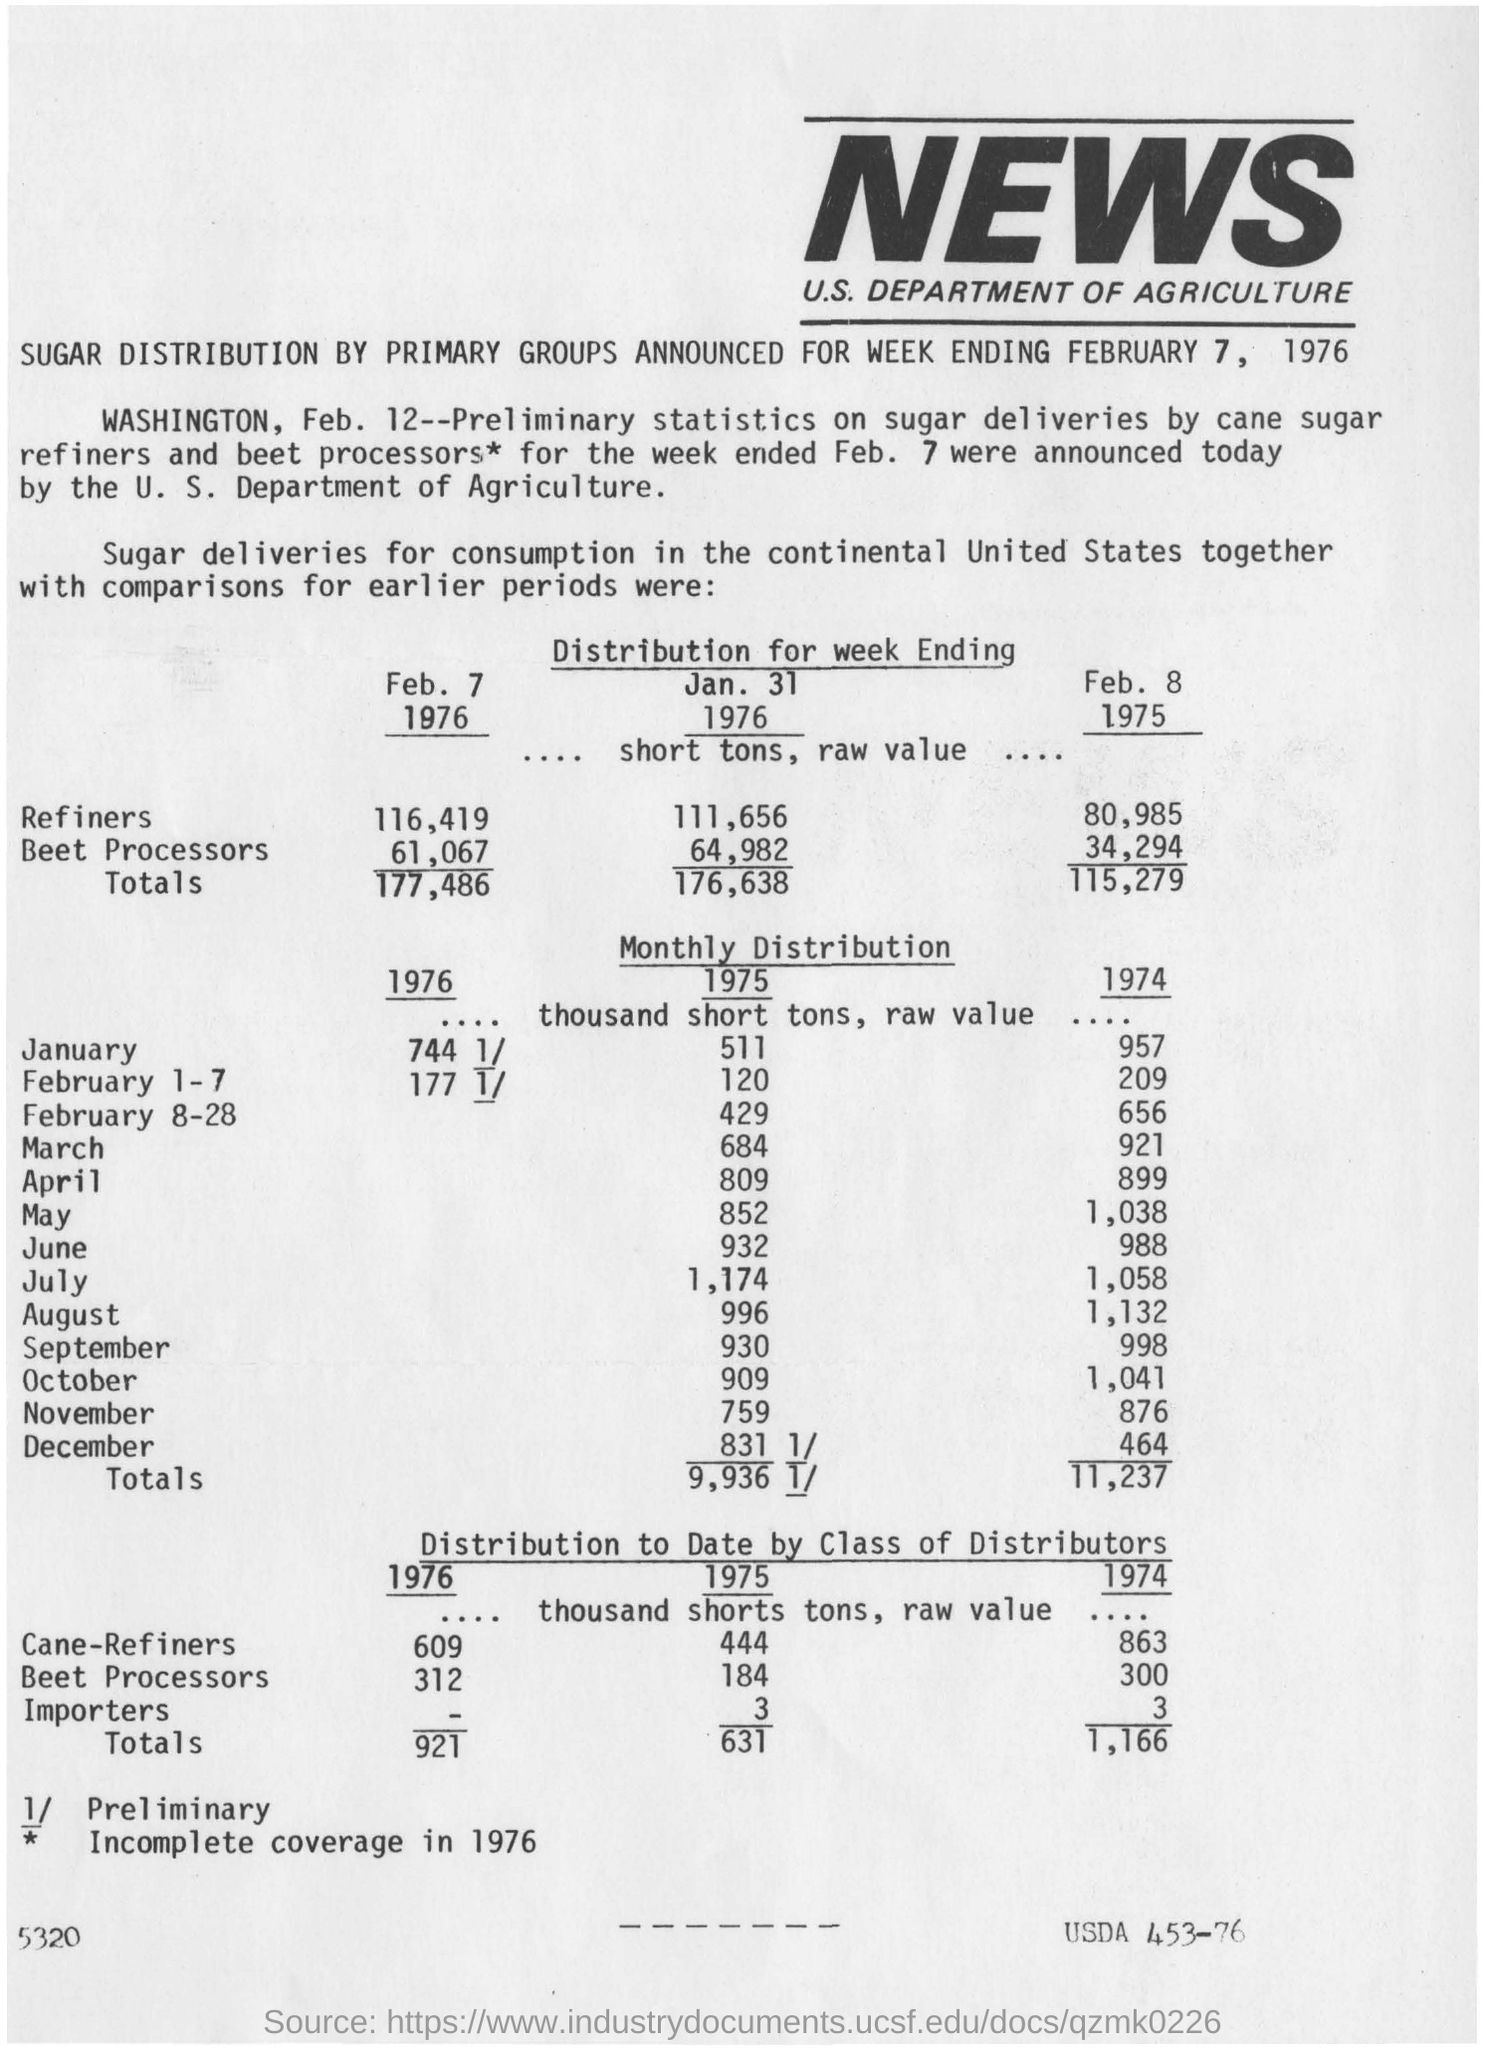Which department's news coverage is this?
Keep it short and to the point. U. S. Department of Agriculture. What is the value corresponding to importers for the year 1975?
Make the answer very short. 3. The article mentions the distribution of which product?
Your answer should be very brief. Sugar. 